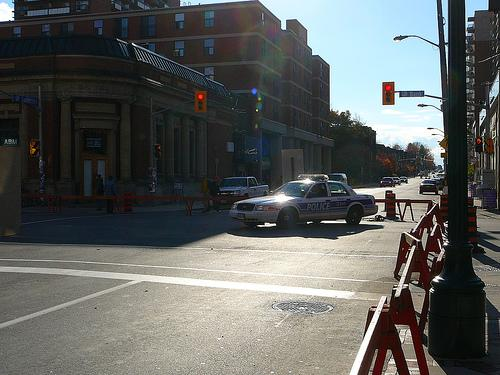Using descriptive words, explain the position of the police car in relation to the barricades. The police car is parked strategically as a roadblock, partially surrounded by fluorescent orange barricades placed on the street. Describe the condition of the traffic in the image, considering the traffic lights and barricades. Traffic appears to be halted or slowed down, as the traffic lights are red and the street is partially blocked with orange barricades. Imagine a storyline for the image and provide a concise and creative title for it. Title: "Roadblock Rendezvous - A Day in the City's Lively Street" Provide a general description of the image and mention at least two primary elements in it. The image depicts a street scene with a police car acting as a roadblock and orange barricades set up around it, while people are standing on the sidewalk. Highlight one human figure in the image and describe their appearance and actions. A man wearing a yellow top is walking near the barricades and the parked police car, possibly observing the scene. List down five prominent objects in the image and their respective colors. 5. Barricades - orange List three objects in the image that are related to public infrastructure and describe their current state. 3. Street light - On (current state not specified) Write a brief caption that summarizes the overall scene in the image. A bustling urban street with a white police car serving as a roadblock, orange barricades, and curious bystanders. Mention what action the police vehicle and one other object in the image are performing. The police vehicle is acting as a roadblock, and a nearby traffic light is showing a red signal. Briefly narrate the possible reason for the police car's presence and the implications on the traffic. The police car may be on the road to handle an emergency or prevent access to a certain area, consequently causing traffic to slow down or stop. 